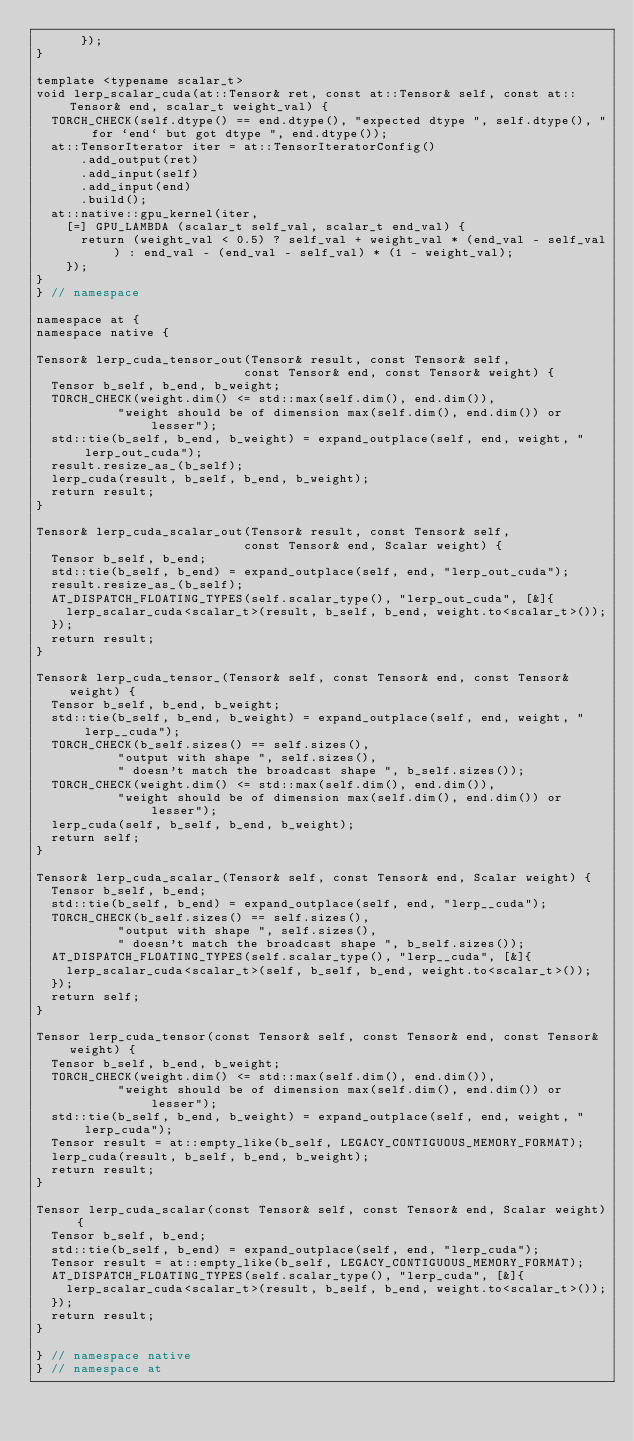Convert code to text. <code><loc_0><loc_0><loc_500><loc_500><_Cuda_>      });
}

template <typename scalar_t>
void lerp_scalar_cuda(at::Tensor& ret, const at::Tensor& self, const at::Tensor& end, scalar_t weight_val) {
  TORCH_CHECK(self.dtype() == end.dtype(), "expected dtype ", self.dtype(), " for `end` but got dtype ", end.dtype());
  at::TensorIterator iter = at::TensorIteratorConfig()
      .add_output(ret)
      .add_input(self)
      .add_input(end)
      .build();
  at::native::gpu_kernel(iter,
    [=] GPU_LAMBDA (scalar_t self_val, scalar_t end_val) {
      return (weight_val < 0.5) ? self_val + weight_val * (end_val - self_val) : end_val - (end_val - self_val) * (1 - weight_val);
    });
}
} // namespace

namespace at {
namespace native {

Tensor& lerp_cuda_tensor_out(Tensor& result, const Tensor& self,
                            const Tensor& end, const Tensor& weight) {
  Tensor b_self, b_end, b_weight;
  TORCH_CHECK(weight.dim() <= std::max(self.dim(), end.dim()),
           "weight should be of dimension max(self.dim(), end.dim()) or lesser");
  std::tie(b_self, b_end, b_weight) = expand_outplace(self, end, weight, "lerp_out_cuda");
  result.resize_as_(b_self);
  lerp_cuda(result, b_self, b_end, b_weight);
  return result;
}

Tensor& lerp_cuda_scalar_out(Tensor& result, const Tensor& self,
                            const Tensor& end, Scalar weight) {
  Tensor b_self, b_end;
  std::tie(b_self, b_end) = expand_outplace(self, end, "lerp_out_cuda");
  result.resize_as_(b_self);
  AT_DISPATCH_FLOATING_TYPES(self.scalar_type(), "lerp_out_cuda", [&]{
    lerp_scalar_cuda<scalar_t>(result, b_self, b_end, weight.to<scalar_t>());
  });
  return result;
}

Tensor& lerp_cuda_tensor_(Tensor& self, const Tensor& end, const Tensor& weight) {
  Tensor b_self, b_end, b_weight;
  std::tie(b_self, b_end, b_weight) = expand_outplace(self, end, weight, "lerp__cuda");
  TORCH_CHECK(b_self.sizes() == self.sizes(),
           "output with shape ", self.sizes(),
           " doesn't match the broadcast shape ", b_self.sizes());
  TORCH_CHECK(weight.dim() <= std::max(self.dim(), end.dim()),
           "weight should be of dimension max(self.dim(), end.dim()) or lesser");
  lerp_cuda(self, b_self, b_end, b_weight);
  return self;
}

Tensor& lerp_cuda_scalar_(Tensor& self, const Tensor& end, Scalar weight) {
  Tensor b_self, b_end;
  std::tie(b_self, b_end) = expand_outplace(self, end, "lerp__cuda");
  TORCH_CHECK(b_self.sizes() == self.sizes(),
           "output with shape ", self.sizes(),
           " doesn't match the broadcast shape ", b_self.sizes());
  AT_DISPATCH_FLOATING_TYPES(self.scalar_type(), "lerp__cuda", [&]{
    lerp_scalar_cuda<scalar_t>(self, b_self, b_end, weight.to<scalar_t>());
  });
  return self;
}

Tensor lerp_cuda_tensor(const Tensor& self, const Tensor& end, const Tensor& weight) {
  Tensor b_self, b_end, b_weight;
  TORCH_CHECK(weight.dim() <= std::max(self.dim(), end.dim()),
           "weight should be of dimension max(self.dim(), end.dim()) or lesser");
  std::tie(b_self, b_end, b_weight) = expand_outplace(self, end, weight, "lerp_cuda");
  Tensor result = at::empty_like(b_self, LEGACY_CONTIGUOUS_MEMORY_FORMAT);
  lerp_cuda(result, b_self, b_end, b_weight);
  return result;
}

Tensor lerp_cuda_scalar(const Tensor& self, const Tensor& end, Scalar weight) {
  Tensor b_self, b_end;
  std::tie(b_self, b_end) = expand_outplace(self, end, "lerp_cuda");
  Tensor result = at::empty_like(b_self, LEGACY_CONTIGUOUS_MEMORY_FORMAT);
  AT_DISPATCH_FLOATING_TYPES(self.scalar_type(), "lerp_cuda", [&]{
    lerp_scalar_cuda<scalar_t>(result, b_self, b_end, weight.to<scalar_t>());
  });
  return result;
}

} // namespace native
} // namespace at
</code> 